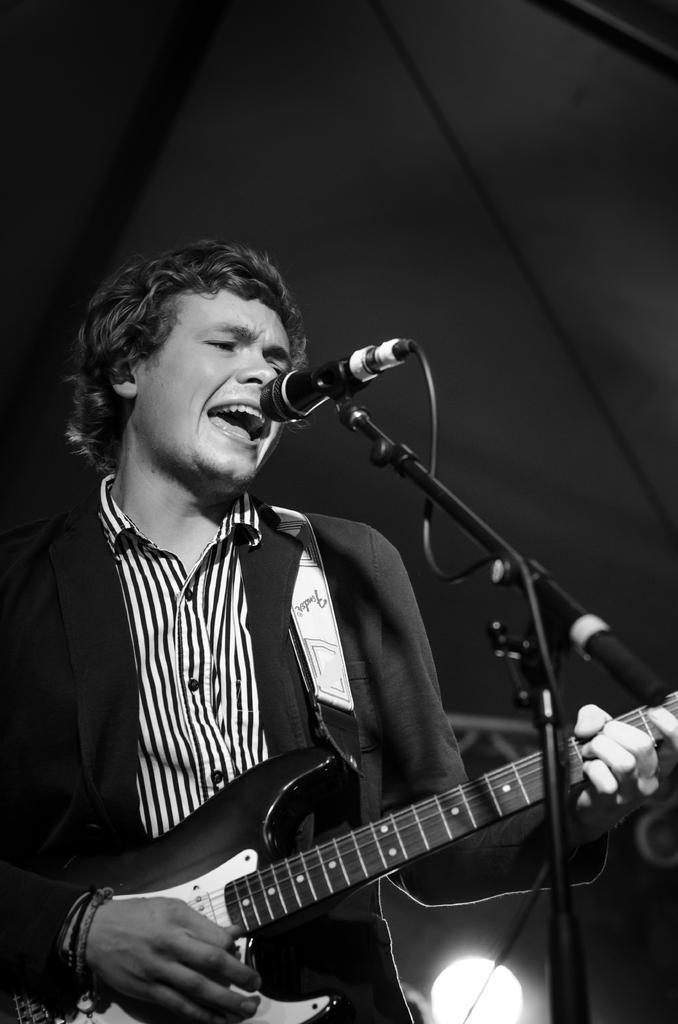In one or two sentences, can you explain what this image depicts? This picture shows a man standing and playing guitar and singing with the help of a microphone 